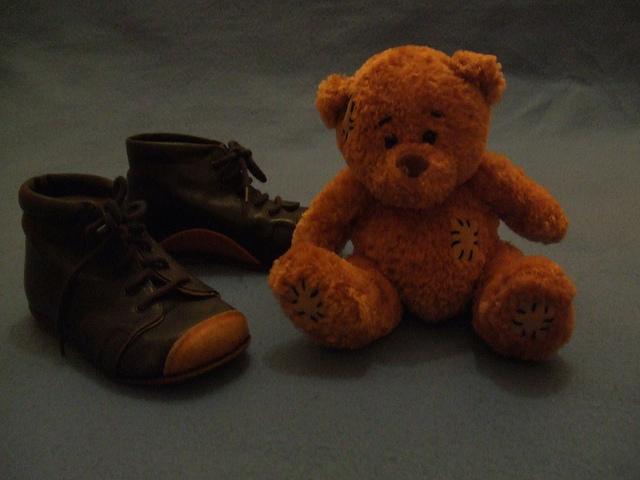How many real people are pictured?
Give a very brief answer. 0. 